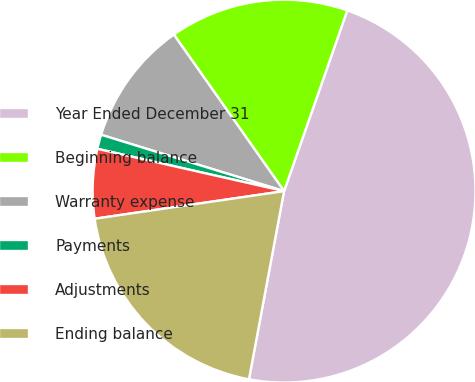Convert chart to OTSL. <chart><loc_0><loc_0><loc_500><loc_500><pie_chart><fcel>Year Ended December 31<fcel>Beginning balance<fcel>Warranty expense<fcel>Payments<fcel>Adjustments<fcel>Ending balance<nl><fcel>47.58%<fcel>15.12%<fcel>10.48%<fcel>1.21%<fcel>5.85%<fcel>19.76%<nl></chart> 